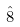Convert formula to latex. <formula><loc_0><loc_0><loc_500><loc_500>\hat { 8 }</formula> 